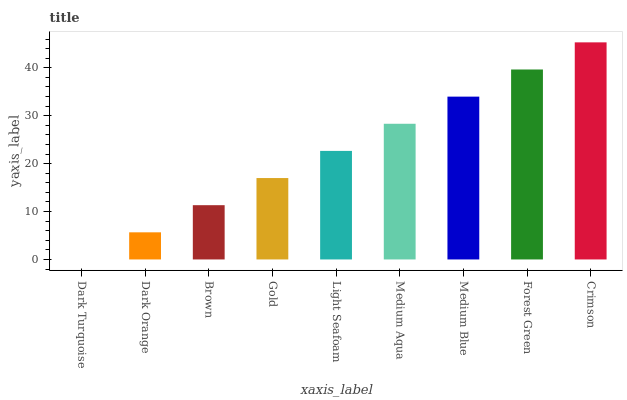Is Dark Turquoise the minimum?
Answer yes or no. Yes. Is Crimson the maximum?
Answer yes or no. Yes. Is Dark Orange the minimum?
Answer yes or no. No. Is Dark Orange the maximum?
Answer yes or no. No. Is Dark Orange greater than Dark Turquoise?
Answer yes or no. Yes. Is Dark Turquoise less than Dark Orange?
Answer yes or no. Yes. Is Dark Turquoise greater than Dark Orange?
Answer yes or no. No. Is Dark Orange less than Dark Turquoise?
Answer yes or no. No. Is Light Seafoam the high median?
Answer yes or no. Yes. Is Light Seafoam the low median?
Answer yes or no. Yes. Is Medium Blue the high median?
Answer yes or no. No. Is Medium Blue the low median?
Answer yes or no. No. 